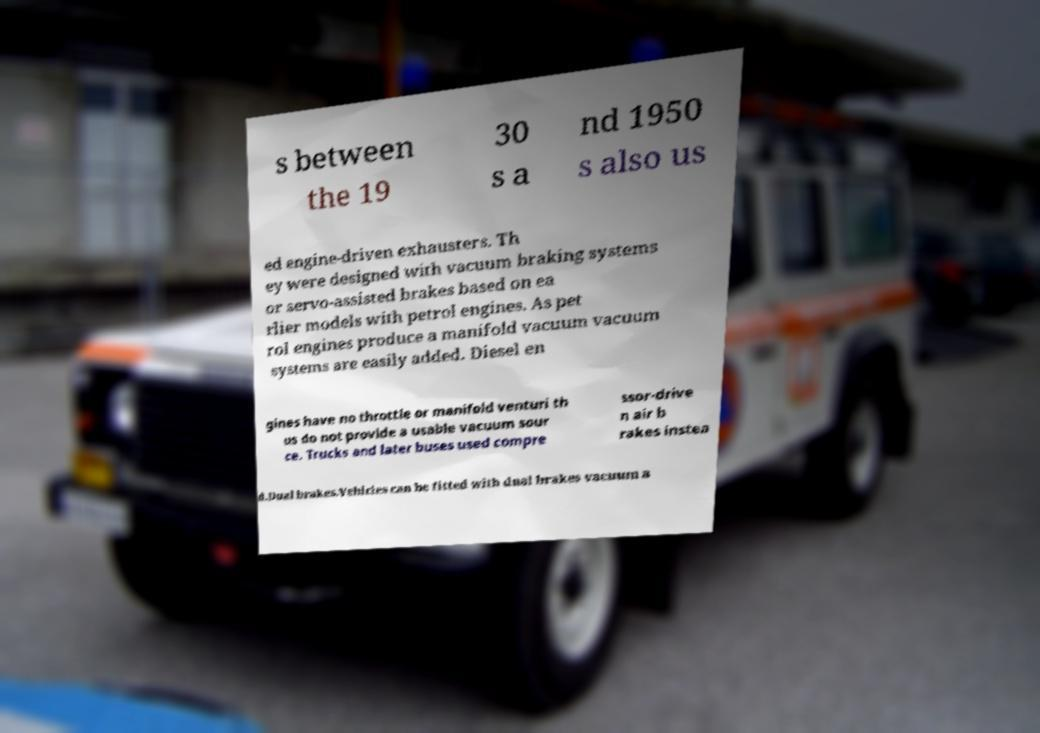Please read and relay the text visible in this image. What does it say? s between the 19 30 s a nd 1950 s also us ed engine-driven exhausters. Th ey were designed with vacuum braking systems or servo-assisted brakes based on ea rlier models with petrol engines. As pet rol engines produce a manifold vacuum vacuum systems are easily added. Diesel en gines have no throttle or manifold venturi th us do not provide a usable vacuum sour ce. Trucks and later buses used compre ssor-drive n air b rakes instea d.Dual brakes.Vehicles can be fitted with dual brakes vacuum a 